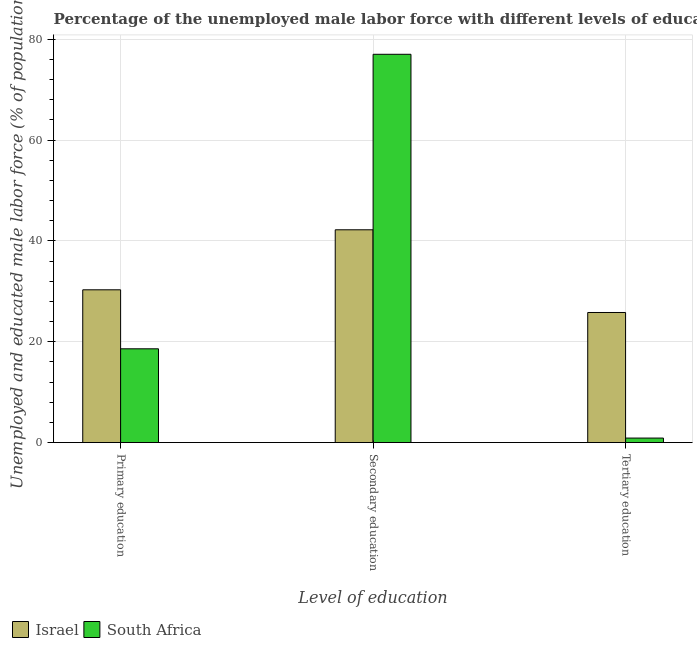How many different coloured bars are there?
Your answer should be compact. 2. Are the number of bars on each tick of the X-axis equal?
Offer a terse response. Yes. What is the label of the 2nd group of bars from the left?
Give a very brief answer. Secondary education. Across all countries, what is the maximum percentage of male labor force who received primary education?
Keep it short and to the point. 30.3. Across all countries, what is the minimum percentage of male labor force who received secondary education?
Provide a short and direct response. 42.2. In which country was the percentage of male labor force who received tertiary education maximum?
Offer a very short reply. Israel. In which country was the percentage of male labor force who received primary education minimum?
Your response must be concise. South Africa. What is the total percentage of male labor force who received tertiary education in the graph?
Keep it short and to the point. 26.7. What is the difference between the percentage of male labor force who received primary education in Israel and that in South Africa?
Your answer should be very brief. 11.7. What is the difference between the percentage of male labor force who received tertiary education in Israel and the percentage of male labor force who received secondary education in South Africa?
Make the answer very short. -51.2. What is the average percentage of male labor force who received tertiary education per country?
Your answer should be very brief. 13.35. What is the difference between the percentage of male labor force who received primary education and percentage of male labor force who received secondary education in Israel?
Keep it short and to the point. -11.9. In how many countries, is the percentage of male labor force who received primary education greater than 76 %?
Provide a succinct answer. 0. What is the ratio of the percentage of male labor force who received secondary education in South Africa to that in Israel?
Make the answer very short. 1.82. Is the difference between the percentage of male labor force who received secondary education in Israel and South Africa greater than the difference between the percentage of male labor force who received primary education in Israel and South Africa?
Your answer should be compact. No. What is the difference between the highest and the second highest percentage of male labor force who received tertiary education?
Keep it short and to the point. 24.9. What is the difference between the highest and the lowest percentage of male labor force who received primary education?
Ensure brevity in your answer.  11.7. What does the 1st bar from the left in Tertiary education represents?
Keep it short and to the point. Israel. Are all the bars in the graph horizontal?
Ensure brevity in your answer.  No. How many countries are there in the graph?
Offer a very short reply. 2. Are the values on the major ticks of Y-axis written in scientific E-notation?
Your response must be concise. No. Does the graph contain grids?
Your answer should be very brief. Yes. Where does the legend appear in the graph?
Provide a short and direct response. Bottom left. How are the legend labels stacked?
Offer a terse response. Horizontal. What is the title of the graph?
Make the answer very short. Percentage of the unemployed male labor force with different levels of education in countries. What is the label or title of the X-axis?
Provide a succinct answer. Level of education. What is the label or title of the Y-axis?
Offer a very short reply. Unemployed and educated male labor force (% of population). What is the Unemployed and educated male labor force (% of population) in Israel in Primary education?
Give a very brief answer. 30.3. What is the Unemployed and educated male labor force (% of population) of South Africa in Primary education?
Provide a succinct answer. 18.6. What is the Unemployed and educated male labor force (% of population) in Israel in Secondary education?
Provide a short and direct response. 42.2. What is the Unemployed and educated male labor force (% of population) in South Africa in Secondary education?
Ensure brevity in your answer.  77. What is the Unemployed and educated male labor force (% of population) in Israel in Tertiary education?
Provide a succinct answer. 25.8. What is the Unemployed and educated male labor force (% of population) of South Africa in Tertiary education?
Give a very brief answer. 0.9. Across all Level of education, what is the maximum Unemployed and educated male labor force (% of population) of Israel?
Provide a short and direct response. 42.2. Across all Level of education, what is the minimum Unemployed and educated male labor force (% of population) of Israel?
Ensure brevity in your answer.  25.8. Across all Level of education, what is the minimum Unemployed and educated male labor force (% of population) of South Africa?
Your answer should be very brief. 0.9. What is the total Unemployed and educated male labor force (% of population) in Israel in the graph?
Provide a short and direct response. 98.3. What is the total Unemployed and educated male labor force (% of population) in South Africa in the graph?
Offer a very short reply. 96.5. What is the difference between the Unemployed and educated male labor force (% of population) in South Africa in Primary education and that in Secondary education?
Your answer should be compact. -58.4. What is the difference between the Unemployed and educated male labor force (% of population) of South Africa in Primary education and that in Tertiary education?
Offer a very short reply. 17.7. What is the difference between the Unemployed and educated male labor force (% of population) in Israel in Secondary education and that in Tertiary education?
Offer a terse response. 16.4. What is the difference between the Unemployed and educated male labor force (% of population) of South Africa in Secondary education and that in Tertiary education?
Offer a very short reply. 76.1. What is the difference between the Unemployed and educated male labor force (% of population) in Israel in Primary education and the Unemployed and educated male labor force (% of population) in South Africa in Secondary education?
Your answer should be very brief. -46.7. What is the difference between the Unemployed and educated male labor force (% of population) of Israel in Primary education and the Unemployed and educated male labor force (% of population) of South Africa in Tertiary education?
Provide a short and direct response. 29.4. What is the difference between the Unemployed and educated male labor force (% of population) in Israel in Secondary education and the Unemployed and educated male labor force (% of population) in South Africa in Tertiary education?
Keep it short and to the point. 41.3. What is the average Unemployed and educated male labor force (% of population) of Israel per Level of education?
Provide a succinct answer. 32.77. What is the average Unemployed and educated male labor force (% of population) of South Africa per Level of education?
Your response must be concise. 32.17. What is the difference between the Unemployed and educated male labor force (% of population) of Israel and Unemployed and educated male labor force (% of population) of South Africa in Secondary education?
Ensure brevity in your answer.  -34.8. What is the difference between the Unemployed and educated male labor force (% of population) of Israel and Unemployed and educated male labor force (% of population) of South Africa in Tertiary education?
Your answer should be very brief. 24.9. What is the ratio of the Unemployed and educated male labor force (% of population) in Israel in Primary education to that in Secondary education?
Give a very brief answer. 0.72. What is the ratio of the Unemployed and educated male labor force (% of population) in South Africa in Primary education to that in Secondary education?
Your answer should be compact. 0.24. What is the ratio of the Unemployed and educated male labor force (% of population) in Israel in Primary education to that in Tertiary education?
Your response must be concise. 1.17. What is the ratio of the Unemployed and educated male labor force (% of population) of South Africa in Primary education to that in Tertiary education?
Provide a short and direct response. 20.67. What is the ratio of the Unemployed and educated male labor force (% of population) in Israel in Secondary education to that in Tertiary education?
Keep it short and to the point. 1.64. What is the ratio of the Unemployed and educated male labor force (% of population) in South Africa in Secondary education to that in Tertiary education?
Provide a short and direct response. 85.56. What is the difference between the highest and the second highest Unemployed and educated male labor force (% of population) of South Africa?
Your response must be concise. 58.4. What is the difference between the highest and the lowest Unemployed and educated male labor force (% of population) in Israel?
Provide a short and direct response. 16.4. What is the difference between the highest and the lowest Unemployed and educated male labor force (% of population) of South Africa?
Your response must be concise. 76.1. 